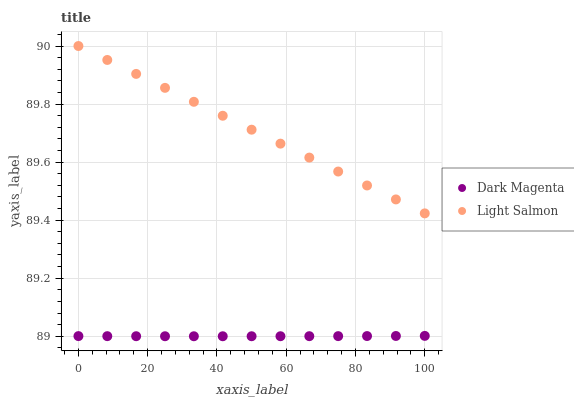Does Dark Magenta have the minimum area under the curve?
Answer yes or no. Yes. Does Light Salmon have the maximum area under the curve?
Answer yes or no. Yes. Does Dark Magenta have the maximum area under the curve?
Answer yes or no. No. Is Light Salmon the smoothest?
Answer yes or no. Yes. Is Dark Magenta the roughest?
Answer yes or no. Yes. Is Dark Magenta the smoothest?
Answer yes or no. No. Does Dark Magenta have the lowest value?
Answer yes or no. Yes. Does Light Salmon have the highest value?
Answer yes or no. Yes. Does Dark Magenta have the highest value?
Answer yes or no. No. Is Dark Magenta less than Light Salmon?
Answer yes or no. Yes. Is Light Salmon greater than Dark Magenta?
Answer yes or no. Yes. Does Dark Magenta intersect Light Salmon?
Answer yes or no. No. 